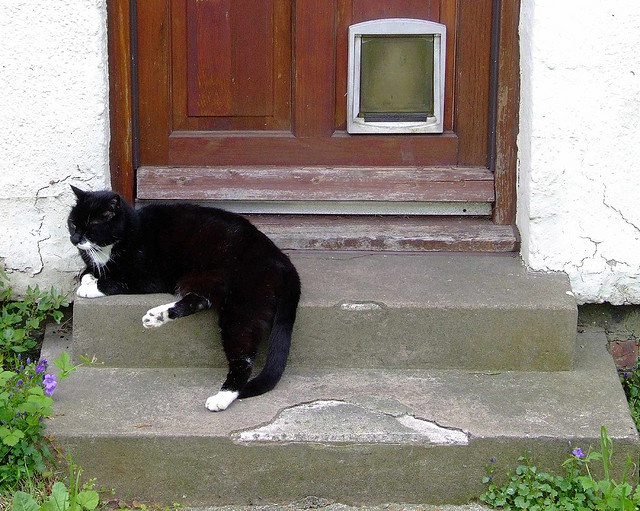Describe the objects in this image and their specific colors. I can see a cat in white, black, gray, and darkgray tones in this image. 